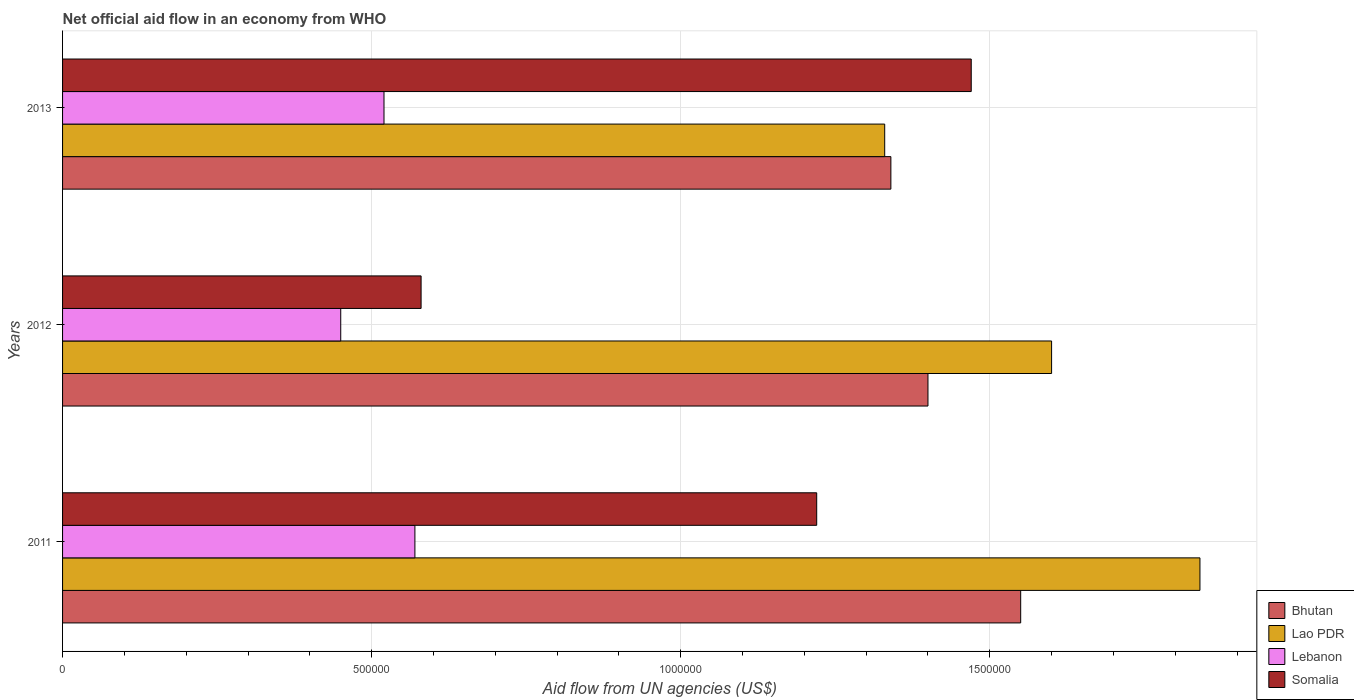How many different coloured bars are there?
Provide a succinct answer. 4. Are the number of bars per tick equal to the number of legend labels?
Offer a terse response. Yes. Are the number of bars on each tick of the Y-axis equal?
Give a very brief answer. Yes. In how many cases, is the number of bars for a given year not equal to the number of legend labels?
Provide a succinct answer. 0. What is the net official aid flow in Bhutan in 2013?
Your answer should be compact. 1.34e+06. Across all years, what is the maximum net official aid flow in Lao PDR?
Give a very brief answer. 1.84e+06. Across all years, what is the minimum net official aid flow in Lebanon?
Make the answer very short. 4.50e+05. In which year was the net official aid flow in Lao PDR maximum?
Your answer should be very brief. 2011. What is the total net official aid flow in Lao PDR in the graph?
Offer a very short reply. 4.77e+06. What is the difference between the net official aid flow in Lao PDR in 2011 and the net official aid flow in Bhutan in 2013?
Your response must be concise. 5.00e+05. What is the average net official aid flow in Bhutan per year?
Your response must be concise. 1.43e+06. In how many years, is the net official aid flow in Bhutan greater than 400000 US$?
Ensure brevity in your answer.  3. What is the ratio of the net official aid flow in Bhutan in 2011 to that in 2012?
Your answer should be very brief. 1.11. Is the net official aid flow in Lebanon in 2012 less than that in 2013?
Offer a very short reply. Yes. What is the difference between the highest and the second highest net official aid flow in Bhutan?
Make the answer very short. 1.50e+05. What is the difference between the highest and the lowest net official aid flow in Lao PDR?
Ensure brevity in your answer.  5.10e+05. Is the sum of the net official aid flow in Lao PDR in 2011 and 2013 greater than the maximum net official aid flow in Bhutan across all years?
Give a very brief answer. Yes. Is it the case that in every year, the sum of the net official aid flow in Somalia and net official aid flow in Bhutan is greater than the sum of net official aid flow in Lao PDR and net official aid flow in Lebanon?
Your response must be concise. No. What does the 1st bar from the top in 2013 represents?
Provide a succinct answer. Somalia. What does the 1st bar from the bottom in 2011 represents?
Provide a short and direct response. Bhutan. Is it the case that in every year, the sum of the net official aid flow in Somalia and net official aid flow in Lao PDR is greater than the net official aid flow in Lebanon?
Keep it short and to the point. Yes. How many bars are there?
Your response must be concise. 12. How many years are there in the graph?
Your response must be concise. 3. Are the values on the major ticks of X-axis written in scientific E-notation?
Your response must be concise. No. How are the legend labels stacked?
Provide a succinct answer. Vertical. What is the title of the graph?
Your answer should be compact. Net official aid flow in an economy from WHO. What is the label or title of the X-axis?
Provide a short and direct response. Aid flow from UN agencies (US$). What is the Aid flow from UN agencies (US$) in Bhutan in 2011?
Offer a terse response. 1.55e+06. What is the Aid flow from UN agencies (US$) of Lao PDR in 2011?
Keep it short and to the point. 1.84e+06. What is the Aid flow from UN agencies (US$) in Lebanon in 2011?
Provide a succinct answer. 5.70e+05. What is the Aid flow from UN agencies (US$) of Somalia in 2011?
Give a very brief answer. 1.22e+06. What is the Aid flow from UN agencies (US$) of Bhutan in 2012?
Give a very brief answer. 1.40e+06. What is the Aid flow from UN agencies (US$) in Lao PDR in 2012?
Your answer should be compact. 1.60e+06. What is the Aid flow from UN agencies (US$) in Lebanon in 2012?
Offer a terse response. 4.50e+05. What is the Aid flow from UN agencies (US$) in Somalia in 2012?
Your answer should be very brief. 5.80e+05. What is the Aid flow from UN agencies (US$) in Bhutan in 2013?
Your answer should be very brief. 1.34e+06. What is the Aid flow from UN agencies (US$) in Lao PDR in 2013?
Offer a very short reply. 1.33e+06. What is the Aid flow from UN agencies (US$) in Lebanon in 2013?
Give a very brief answer. 5.20e+05. What is the Aid flow from UN agencies (US$) in Somalia in 2013?
Your answer should be very brief. 1.47e+06. Across all years, what is the maximum Aid flow from UN agencies (US$) of Bhutan?
Provide a succinct answer. 1.55e+06. Across all years, what is the maximum Aid flow from UN agencies (US$) of Lao PDR?
Your answer should be very brief. 1.84e+06. Across all years, what is the maximum Aid flow from UN agencies (US$) of Lebanon?
Your answer should be very brief. 5.70e+05. Across all years, what is the maximum Aid flow from UN agencies (US$) of Somalia?
Provide a succinct answer. 1.47e+06. Across all years, what is the minimum Aid flow from UN agencies (US$) in Bhutan?
Offer a very short reply. 1.34e+06. Across all years, what is the minimum Aid flow from UN agencies (US$) in Lao PDR?
Make the answer very short. 1.33e+06. Across all years, what is the minimum Aid flow from UN agencies (US$) of Somalia?
Offer a very short reply. 5.80e+05. What is the total Aid flow from UN agencies (US$) of Bhutan in the graph?
Keep it short and to the point. 4.29e+06. What is the total Aid flow from UN agencies (US$) of Lao PDR in the graph?
Keep it short and to the point. 4.77e+06. What is the total Aid flow from UN agencies (US$) in Lebanon in the graph?
Your answer should be compact. 1.54e+06. What is the total Aid flow from UN agencies (US$) of Somalia in the graph?
Provide a short and direct response. 3.27e+06. What is the difference between the Aid flow from UN agencies (US$) of Lao PDR in 2011 and that in 2012?
Give a very brief answer. 2.40e+05. What is the difference between the Aid flow from UN agencies (US$) of Somalia in 2011 and that in 2012?
Provide a short and direct response. 6.40e+05. What is the difference between the Aid flow from UN agencies (US$) of Lao PDR in 2011 and that in 2013?
Offer a terse response. 5.10e+05. What is the difference between the Aid flow from UN agencies (US$) in Bhutan in 2012 and that in 2013?
Your response must be concise. 6.00e+04. What is the difference between the Aid flow from UN agencies (US$) in Somalia in 2012 and that in 2013?
Give a very brief answer. -8.90e+05. What is the difference between the Aid flow from UN agencies (US$) in Bhutan in 2011 and the Aid flow from UN agencies (US$) in Lebanon in 2012?
Provide a succinct answer. 1.10e+06. What is the difference between the Aid flow from UN agencies (US$) in Bhutan in 2011 and the Aid flow from UN agencies (US$) in Somalia in 2012?
Keep it short and to the point. 9.70e+05. What is the difference between the Aid flow from UN agencies (US$) of Lao PDR in 2011 and the Aid flow from UN agencies (US$) of Lebanon in 2012?
Keep it short and to the point. 1.39e+06. What is the difference between the Aid flow from UN agencies (US$) in Lao PDR in 2011 and the Aid flow from UN agencies (US$) in Somalia in 2012?
Keep it short and to the point. 1.26e+06. What is the difference between the Aid flow from UN agencies (US$) of Lebanon in 2011 and the Aid flow from UN agencies (US$) of Somalia in 2012?
Provide a short and direct response. -10000. What is the difference between the Aid flow from UN agencies (US$) of Bhutan in 2011 and the Aid flow from UN agencies (US$) of Lebanon in 2013?
Your answer should be very brief. 1.03e+06. What is the difference between the Aid flow from UN agencies (US$) in Lao PDR in 2011 and the Aid flow from UN agencies (US$) in Lebanon in 2013?
Give a very brief answer. 1.32e+06. What is the difference between the Aid flow from UN agencies (US$) in Lao PDR in 2011 and the Aid flow from UN agencies (US$) in Somalia in 2013?
Keep it short and to the point. 3.70e+05. What is the difference between the Aid flow from UN agencies (US$) in Lebanon in 2011 and the Aid flow from UN agencies (US$) in Somalia in 2013?
Provide a short and direct response. -9.00e+05. What is the difference between the Aid flow from UN agencies (US$) of Bhutan in 2012 and the Aid flow from UN agencies (US$) of Lebanon in 2013?
Keep it short and to the point. 8.80e+05. What is the difference between the Aid flow from UN agencies (US$) of Bhutan in 2012 and the Aid flow from UN agencies (US$) of Somalia in 2013?
Your answer should be compact. -7.00e+04. What is the difference between the Aid flow from UN agencies (US$) of Lao PDR in 2012 and the Aid flow from UN agencies (US$) of Lebanon in 2013?
Offer a very short reply. 1.08e+06. What is the difference between the Aid flow from UN agencies (US$) in Lao PDR in 2012 and the Aid flow from UN agencies (US$) in Somalia in 2013?
Keep it short and to the point. 1.30e+05. What is the difference between the Aid flow from UN agencies (US$) of Lebanon in 2012 and the Aid flow from UN agencies (US$) of Somalia in 2013?
Offer a terse response. -1.02e+06. What is the average Aid flow from UN agencies (US$) of Bhutan per year?
Provide a succinct answer. 1.43e+06. What is the average Aid flow from UN agencies (US$) of Lao PDR per year?
Provide a short and direct response. 1.59e+06. What is the average Aid flow from UN agencies (US$) in Lebanon per year?
Your response must be concise. 5.13e+05. What is the average Aid flow from UN agencies (US$) of Somalia per year?
Provide a short and direct response. 1.09e+06. In the year 2011, what is the difference between the Aid flow from UN agencies (US$) in Bhutan and Aid flow from UN agencies (US$) in Lao PDR?
Your answer should be very brief. -2.90e+05. In the year 2011, what is the difference between the Aid flow from UN agencies (US$) of Bhutan and Aid flow from UN agencies (US$) of Lebanon?
Ensure brevity in your answer.  9.80e+05. In the year 2011, what is the difference between the Aid flow from UN agencies (US$) in Lao PDR and Aid flow from UN agencies (US$) in Lebanon?
Give a very brief answer. 1.27e+06. In the year 2011, what is the difference between the Aid flow from UN agencies (US$) in Lao PDR and Aid flow from UN agencies (US$) in Somalia?
Your response must be concise. 6.20e+05. In the year 2011, what is the difference between the Aid flow from UN agencies (US$) in Lebanon and Aid flow from UN agencies (US$) in Somalia?
Make the answer very short. -6.50e+05. In the year 2012, what is the difference between the Aid flow from UN agencies (US$) in Bhutan and Aid flow from UN agencies (US$) in Lebanon?
Your answer should be compact. 9.50e+05. In the year 2012, what is the difference between the Aid flow from UN agencies (US$) of Bhutan and Aid flow from UN agencies (US$) of Somalia?
Your answer should be very brief. 8.20e+05. In the year 2012, what is the difference between the Aid flow from UN agencies (US$) in Lao PDR and Aid flow from UN agencies (US$) in Lebanon?
Give a very brief answer. 1.15e+06. In the year 2012, what is the difference between the Aid flow from UN agencies (US$) in Lao PDR and Aid flow from UN agencies (US$) in Somalia?
Make the answer very short. 1.02e+06. In the year 2012, what is the difference between the Aid flow from UN agencies (US$) in Lebanon and Aid flow from UN agencies (US$) in Somalia?
Provide a succinct answer. -1.30e+05. In the year 2013, what is the difference between the Aid flow from UN agencies (US$) of Bhutan and Aid flow from UN agencies (US$) of Lebanon?
Your response must be concise. 8.20e+05. In the year 2013, what is the difference between the Aid flow from UN agencies (US$) in Bhutan and Aid flow from UN agencies (US$) in Somalia?
Offer a terse response. -1.30e+05. In the year 2013, what is the difference between the Aid flow from UN agencies (US$) in Lao PDR and Aid flow from UN agencies (US$) in Lebanon?
Offer a very short reply. 8.10e+05. In the year 2013, what is the difference between the Aid flow from UN agencies (US$) of Lao PDR and Aid flow from UN agencies (US$) of Somalia?
Your answer should be very brief. -1.40e+05. In the year 2013, what is the difference between the Aid flow from UN agencies (US$) of Lebanon and Aid flow from UN agencies (US$) of Somalia?
Provide a succinct answer. -9.50e+05. What is the ratio of the Aid flow from UN agencies (US$) of Bhutan in 2011 to that in 2012?
Offer a terse response. 1.11. What is the ratio of the Aid flow from UN agencies (US$) of Lao PDR in 2011 to that in 2012?
Give a very brief answer. 1.15. What is the ratio of the Aid flow from UN agencies (US$) of Lebanon in 2011 to that in 2012?
Provide a succinct answer. 1.27. What is the ratio of the Aid flow from UN agencies (US$) in Somalia in 2011 to that in 2012?
Keep it short and to the point. 2.1. What is the ratio of the Aid flow from UN agencies (US$) in Bhutan in 2011 to that in 2013?
Provide a short and direct response. 1.16. What is the ratio of the Aid flow from UN agencies (US$) of Lao PDR in 2011 to that in 2013?
Ensure brevity in your answer.  1.38. What is the ratio of the Aid flow from UN agencies (US$) of Lebanon in 2011 to that in 2013?
Offer a terse response. 1.1. What is the ratio of the Aid flow from UN agencies (US$) of Somalia in 2011 to that in 2013?
Your answer should be very brief. 0.83. What is the ratio of the Aid flow from UN agencies (US$) of Bhutan in 2012 to that in 2013?
Provide a succinct answer. 1.04. What is the ratio of the Aid flow from UN agencies (US$) of Lao PDR in 2012 to that in 2013?
Offer a terse response. 1.2. What is the ratio of the Aid flow from UN agencies (US$) in Lebanon in 2012 to that in 2013?
Keep it short and to the point. 0.87. What is the ratio of the Aid flow from UN agencies (US$) in Somalia in 2012 to that in 2013?
Your answer should be very brief. 0.39. What is the difference between the highest and the second highest Aid flow from UN agencies (US$) in Lebanon?
Provide a succinct answer. 5.00e+04. What is the difference between the highest and the lowest Aid flow from UN agencies (US$) in Lao PDR?
Provide a short and direct response. 5.10e+05. What is the difference between the highest and the lowest Aid flow from UN agencies (US$) in Somalia?
Provide a short and direct response. 8.90e+05. 